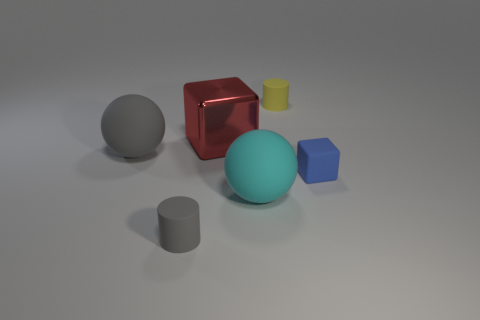Add 4 big blocks. How many objects exist? 10 Subtract all balls. How many objects are left? 4 Subtract all small blue matte things. Subtract all yellow matte cylinders. How many objects are left? 4 Add 5 metal things. How many metal things are left? 6 Add 1 rubber things. How many rubber things exist? 6 Subtract 0 purple cylinders. How many objects are left? 6 